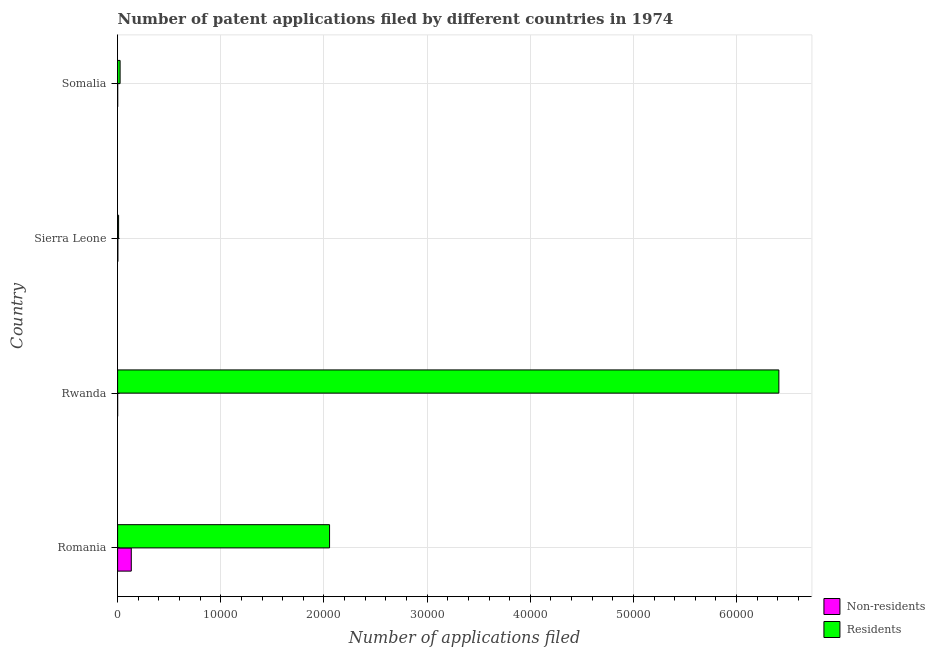Are the number of bars per tick equal to the number of legend labels?
Your answer should be very brief. Yes. How many bars are there on the 1st tick from the top?
Provide a short and direct response. 2. How many bars are there on the 4th tick from the bottom?
Offer a terse response. 2. What is the label of the 2nd group of bars from the top?
Make the answer very short. Sierra Leone. In how many cases, is the number of bars for a given country not equal to the number of legend labels?
Ensure brevity in your answer.  0. What is the number of patent applications by non residents in Romania?
Offer a terse response. 1325. Across all countries, what is the maximum number of patent applications by non residents?
Your response must be concise. 1325. Across all countries, what is the minimum number of patent applications by residents?
Offer a very short reply. 95. In which country was the number of patent applications by non residents maximum?
Ensure brevity in your answer.  Romania. In which country was the number of patent applications by non residents minimum?
Ensure brevity in your answer.  Rwanda. What is the total number of patent applications by non residents in the graph?
Offer a very short reply. 1361. What is the difference between the number of patent applications by non residents in Rwanda and that in Somalia?
Your answer should be compact. -6. What is the difference between the number of patent applications by residents in Romania and the number of patent applications by non residents in Sierra Leone?
Make the answer very short. 2.05e+04. What is the average number of patent applications by non residents per country?
Offer a terse response. 340.25. What is the difference between the number of patent applications by residents and number of patent applications by non residents in Rwanda?
Offer a terse response. 6.41e+04. What is the ratio of the number of patent applications by residents in Rwanda to that in Somalia?
Make the answer very short. 265.95. Is the number of patent applications by residents in Romania less than that in Somalia?
Give a very brief answer. No. What is the difference between the highest and the second highest number of patent applications by residents?
Provide a succinct answer. 4.35e+04. What is the difference between the highest and the lowest number of patent applications by residents?
Your answer should be compact. 6.40e+04. What does the 2nd bar from the top in Sierra Leone represents?
Your answer should be very brief. Non-residents. What does the 1st bar from the bottom in Sierra Leone represents?
Give a very brief answer. Non-residents. How many countries are there in the graph?
Offer a very short reply. 4. Are the values on the major ticks of X-axis written in scientific E-notation?
Your answer should be compact. No. Does the graph contain any zero values?
Offer a terse response. No. Does the graph contain grids?
Provide a short and direct response. Yes. How many legend labels are there?
Your answer should be compact. 2. What is the title of the graph?
Ensure brevity in your answer.  Number of patent applications filed by different countries in 1974. What is the label or title of the X-axis?
Your answer should be compact. Number of applications filed. What is the Number of applications filed in Non-residents in Romania?
Keep it short and to the point. 1325. What is the Number of applications filed of Residents in Romania?
Provide a short and direct response. 2.05e+04. What is the Number of applications filed of Residents in Rwanda?
Ensure brevity in your answer.  6.41e+04. What is the Number of applications filed of Non-residents in Somalia?
Make the answer very short. 8. What is the Number of applications filed of Residents in Somalia?
Your answer should be very brief. 241. Across all countries, what is the maximum Number of applications filed of Non-residents?
Your answer should be very brief. 1325. Across all countries, what is the maximum Number of applications filed of Residents?
Provide a short and direct response. 6.41e+04. Across all countries, what is the minimum Number of applications filed in Non-residents?
Ensure brevity in your answer.  2. What is the total Number of applications filed in Non-residents in the graph?
Keep it short and to the point. 1361. What is the total Number of applications filed in Residents in the graph?
Provide a succinct answer. 8.50e+04. What is the difference between the Number of applications filed in Non-residents in Romania and that in Rwanda?
Offer a terse response. 1323. What is the difference between the Number of applications filed in Residents in Romania and that in Rwanda?
Give a very brief answer. -4.35e+04. What is the difference between the Number of applications filed in Non-residents in Romania and that in Sierra Leone?
Your answer should be compact. 1299. What is the difference between the Number of applications filed of Residents in Romania and that in Sierra Leone?
Ensure brevity in your answer.  2.04e+04. What is the difference between the Number of applications filed in Non-residents in Romania and that in Somalia?
Your answer should be compact. 1317. What is the difference between the Number of applications filed of Residents in Romania and that in Somalia?
Offer a very short reply. 2.03e+04. What is the difference between the Number of applications filed of Non-residents in Rwanda and that in Sierra Leone?
Give a very brief answer. -24. What is the difference between the Number of applications filed of Residents in Rwanda and that in Sierra Leone?
Provide a succinct answer. 6.40e+04. What is the difference between the Number of applications filed of Residents in Rwanda and that in Somalia?
Keep it short and to the point. 6.39e+04. What is the difference between the Number of applications filed in Residents in Sierra Leone and that in Somalia?
Keep it short and to the point. -146. What is the difference between the Number of applications filed in Non-residents in Romania and the Number of applications filed in Residents in Rwanda?
Keep it short and to the point. -6.28e+04. What is the difference between the Number of applications filed of Non-residents in Romania and the Number of applications filed of Residents in Sierra Leone?
Give a very brief answer. 1230. What is the difference between the Number of applications filed of Non-residents in Romania and the Number of applications filed of Residents in Somalia?
Ensure brevity in your answer.  1084. What is the difference between the Number of applications filed of Non-residents in Rwanda and the Number of applications filed of Residents in Sierra Leone?
Your answer should be very brief. -93. What is the difference between the Number of applications filed in Non-residents in Rwanda and the Number of applications filed in Residents in Somalia?
Ensure brevity in your answer.  -239. What is the difference between the Number of applications filed in Non-residents in Sierra Leone and the Number of applications filed in Residents in Somalia?
Give a very brief answer. -215. What is the average Number of applications filed in Non-residents per country?
Ensure brevity in your answer.  340.25. What is the average Number of applications filed of Residents per country?
Make the answer very short. 2.12e+04. What is the difference between the Number of applications filed in Non-residents and Number of applications filed in Residents in Romania?
Offer a terse response. -1.92e+04. What is the difference between the Number of applications filed of Non-residents and Number of applications filed of Residents in Rwanda?
Ensure brevity in your answer.  -6.41e+04. What is the difference between the Number of applications filed in Non-residents and Number of applications filed in Residents in Sierra Leone?
Give a very brief answer. -69. What is the difference between the Number of applications filed in Non-residents and Number of applications filed in Residents in Somalia?
Provide a succinct answer. -233. What is the ratio of the Number of applications filed in Non-residents in Romania to that in Rwanda?
Your answer should be compact. 662.5. What is the ratio of the Number of applications filed of Residents in Romania to that in Rwanda?
Provide a short and direct response. 0.32. What is the ratio of the Number of applications filed of Non-residents in Romania to that in Sierra Leone?
Make the answer very short. 50.96. What is the ratio of the Number of applications filed of Residents in Romania to that in Sierra Leone?
Ensure brevity in your answer.  216.26. What is the ratio of the Number of applications filed of Non-residents in Romania to that in Somalia?
Keep it short and to the point. 165.62. What is the ratio of the Number of applications filed in Residents in Romania to that in Somalia?
Provide a short and direct response. 85.25. What is the ratio of the Number of applications filed of Non-residents in Rwanda to that in Sierra Leone?
Your response must be concise. 0.08. What is the ratio of the Number of applications filed in Residents in Rwanda to that in Sierra Leone?
Provide a succinct answer. 674.66. What is the ratio of the Number of applications filed in Non-residents in Rwanda to that in Somalia?
Give a very brief answer. 0.25. What is the ratio of the Number of applications filed in Residents in Rwanda to that in Somalia?
Make the answer very short. 265.95. What is the ratio of the Number of applications filed of Residents in Sierra Leone to that in Somalia?
Your answer should be very brief. 0.39. What is the difference between the highest and the second highest Number of applications filed in Non-residents?
Your answer should be very brief. 1299. What is the difference between the highest and the second highest Number of applications filed of Residents?
Provide a short and direct response. 4.35e+04. What is the difference between the highest and the lowest Number of applications filed of Non-residents?
Your answer should be very brief. 1323. What is the difference between the highest and the lowest Number of applications filed of Residents?
Provide a short and direct response. 6.40e+04. 